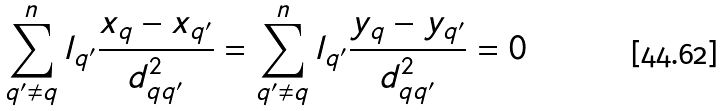Convert formula to latex. <formula><loc_0><loc_0><loc_500><loc_500>\sum ^ { n } _ { q ^ { \prime } \neq q } l _ { q ^ { \prime } } \frac { x _ { q } - x _ { q ^ { \prime } } } { d _ { q q ^ { \prime } } ^ { 2 } } = \sum ^ { n } _ { q ^ { \prime } \neq q } l _ { q ^ { \prime } } \frac { y _ { q } - y _ { q ^ { \prime } } } { d _ { q q ^ { \prime } } ^ { 2 } } = 0</formula> 